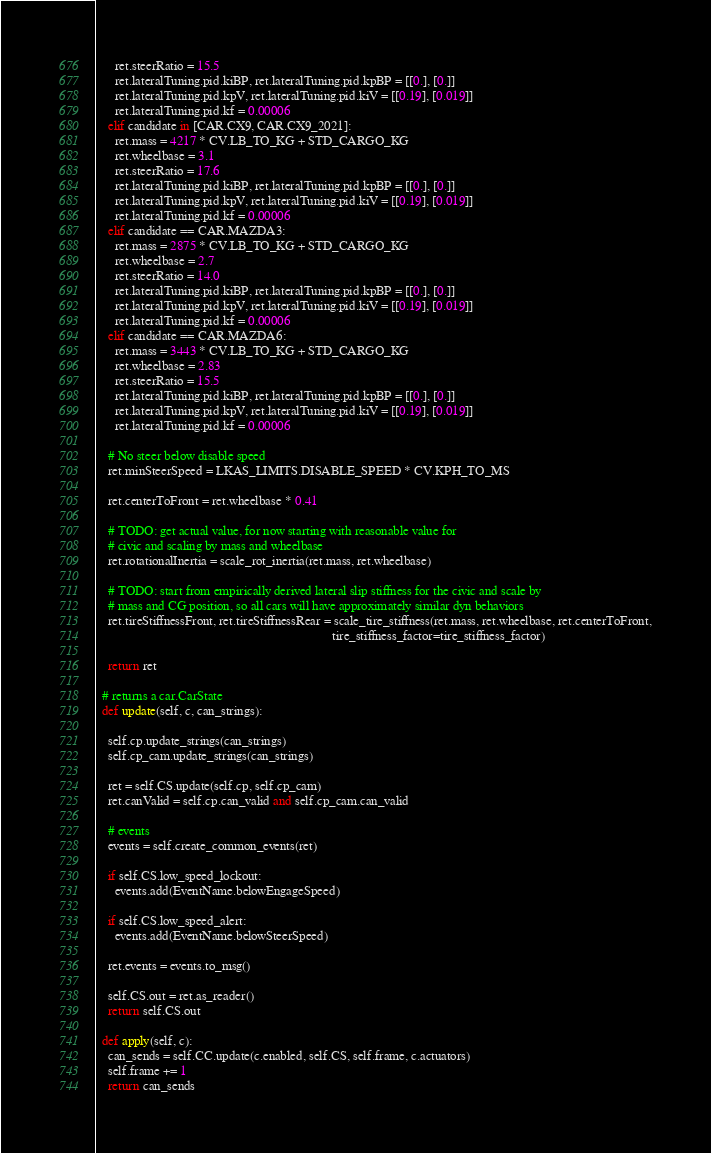Convert code to text. <code><loc_0><loc_0><loc_500><loc_500><_Python_>      ret.steerRatio = 15.5
      ret.lateralTuning.pid.kiBP, ret.lateralTuning.pid.kpBP = [[0.], [0.]]
      ret.lateralTuning.pid.kpV, ret.lateralTuning.pid.kiV = [[0.19], [0.019]]
      ret.lateralTuning.pid.kf = 0.00006
    elif candidate in [CAR.CX9, CAR.CX9_2021]:
      ret.mass = 4217 * CV.LB_TO_KG + STD_CARGO_KG
      ret.wheelbase = 3.1
      ret.steerRatio = 17.6
      ret.lateralTuning.pid.kiBP, ret.lateralTuning.pid.kpBP = [[0.], [0.]]
      ret.lateralTuning.pid.kpV, ret.lateralTuning.pid.kiV = [[0.19], [0.019]]
      ret.lateralTuning.pid.kf = 0.00006
    elif candidate == CAR.MAZDA3:
      ret.mass = 2875 * CV.LB_TO_KG + STD_CARGO_KG
      ret.wheelbase = 2.7
      ret.steerRatio = 14.0
      ret.lateralTuning.pid.kiBP, ret.lateralTuning.pid.kpBP = [[0.], [0.]]
      ret.lateralTuning.pid.kpV, ret.lateralTuning.pid.kiV = [[0.19], [0.019]]
      ret.lateralTuning.pid.kf = 0.00006
    elif candidate == CAR.MAZDA6:
      ret.mass = 3443 * CV.LB_TO_KG + STD_CARGO_KG
      ret.wheelbase = 2.83
      ret.steerRatio = 15.5
      ret.lateralTuning.pid.kiBP, ret.lateralTuning.pid.kpBP = [[0.], [0.]]
      ret.lateralTuning.pid.kpV, ret.lateralTuning.pid.kiV = [[0.19], [0.019]]
      ret.lateralTuning.pid.kf = 0.00006

    # No steer below disable speed
    ret.minSteerSpeed = LKAS_LIMITS.DISABLE_SPEED * CV.KPH_TO_MS

    ret.centerToFront = ret.wheelbase * 0.41

    # TODO: get actual value, for now starting with reasonable value for
    # civic and scaling by mass and wheelbase
    ret.rotationalInertia = scale_rot_inertia(ret.mass, ret.wheelbase)

    # TODO: start from empirically derived lateral slip stiffness for the civic and scale by
    # mass and CG position, so all cars will have approximately similar dyn behaviors
    ret.tireStiffnessFront, ret.tireStiffnessRear = scale_tire_stiffness(ret.mass, ret.wheelbase, ret.centerToFront,
                                                                         tire_stiffness_factor=tire_stiffness_factor)

    return ret

  # returns a car.CarState
  def update(self, c, can_strings):

    self.cp.update_strings(can_strings)
    self.cp_cam.update_strings(can_strings)

    ret = self.CS.update(self.cp, self.cp_cam)
    ret.canValid = self.cp.can_valid and self.cp_cam.can_valid

    # events
    events = self.create_common_events(ret)

    if self.CS.low_speed_lockout:
      events.add(EventName.belowEngageSpeed)

    if self.CS.low_speed_alert:
      events.add(EventName.belowSteerSpeed)

    ret.events = events.to_msg()

    self.CS.out = ret.as_reader()
    return self.CS.out

  def apply(self, c):
    can_sends = self.CC.update(c.enabled, self.CS, self.frame, c.actuators)
    self.frame += 1
    return can_sends
</code> 